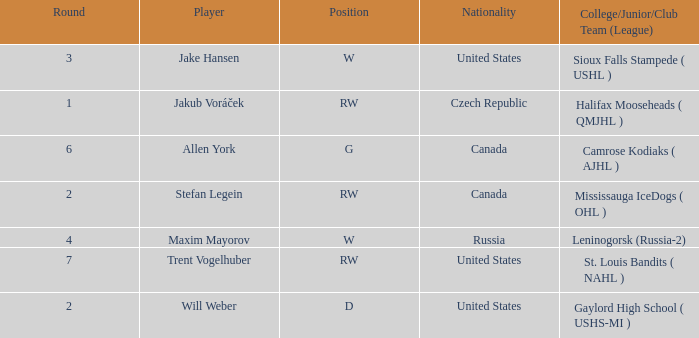What nationality is the draft pick with w position from leninogorsk (russia-2)? Russia. 